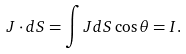<formula> <loc_0><loc_0><loc_500><loc_500>J \cdot d S = \int J d S \cos \theta = I .</formula> 